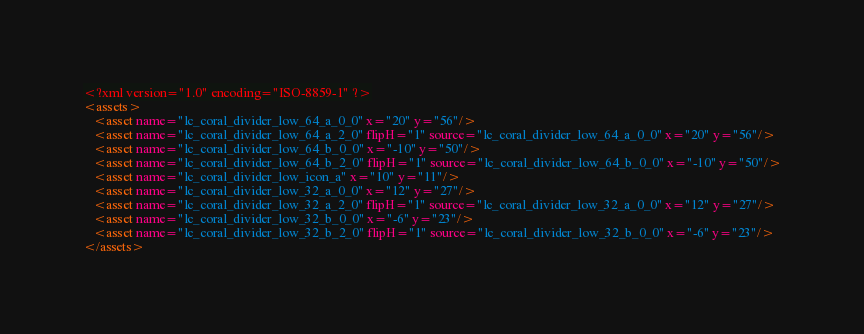<code> <loc_0><loc_0><loc_500><loc_500><_XML_><?xml version="1.0" encoding="ISO-8859-1" ?>
<assets>
   <asset name="lc_coral_divider_low_64_a_0_0" x="20" y="56"/>
   <asset name="lc_coral_divider_low_64_a_2_0" flipH="1" source="lc_coral_divider_low_64_a_0_0" x="20" y="56"/>
   <asset name="lc_coral_divider_low_64_b_0_0" x="-10" y="50"/>
   <asset name="lc_coral_divider_low_64_b_2_0" flipH="1" source="lc_coral_divider_low_64_b_0_0" x="-10" y="50"/>
   <asset name="lc_coral_divider_low_icon_a" x="10" y="11"/>
   <asset name="lc_coral_divider_low_32_a_0_0" x="12" y="27"/>
   <asset name="lc_coral_divider_low_32_a_2_0" flipH="1" source="lc_coral_divider_low_32_a_0_0" x="12" y="27"/>
   <asset name="lc_coral_divider_low_32_b_0_0" x="-6" y="23"/>
   <asset name="lc_coral_divider_low_32_b_2_0" flipH="1" source="lc_coral_divider_low_32_b_0_0" x="-6" y="23"/>
</assets>
</code> 